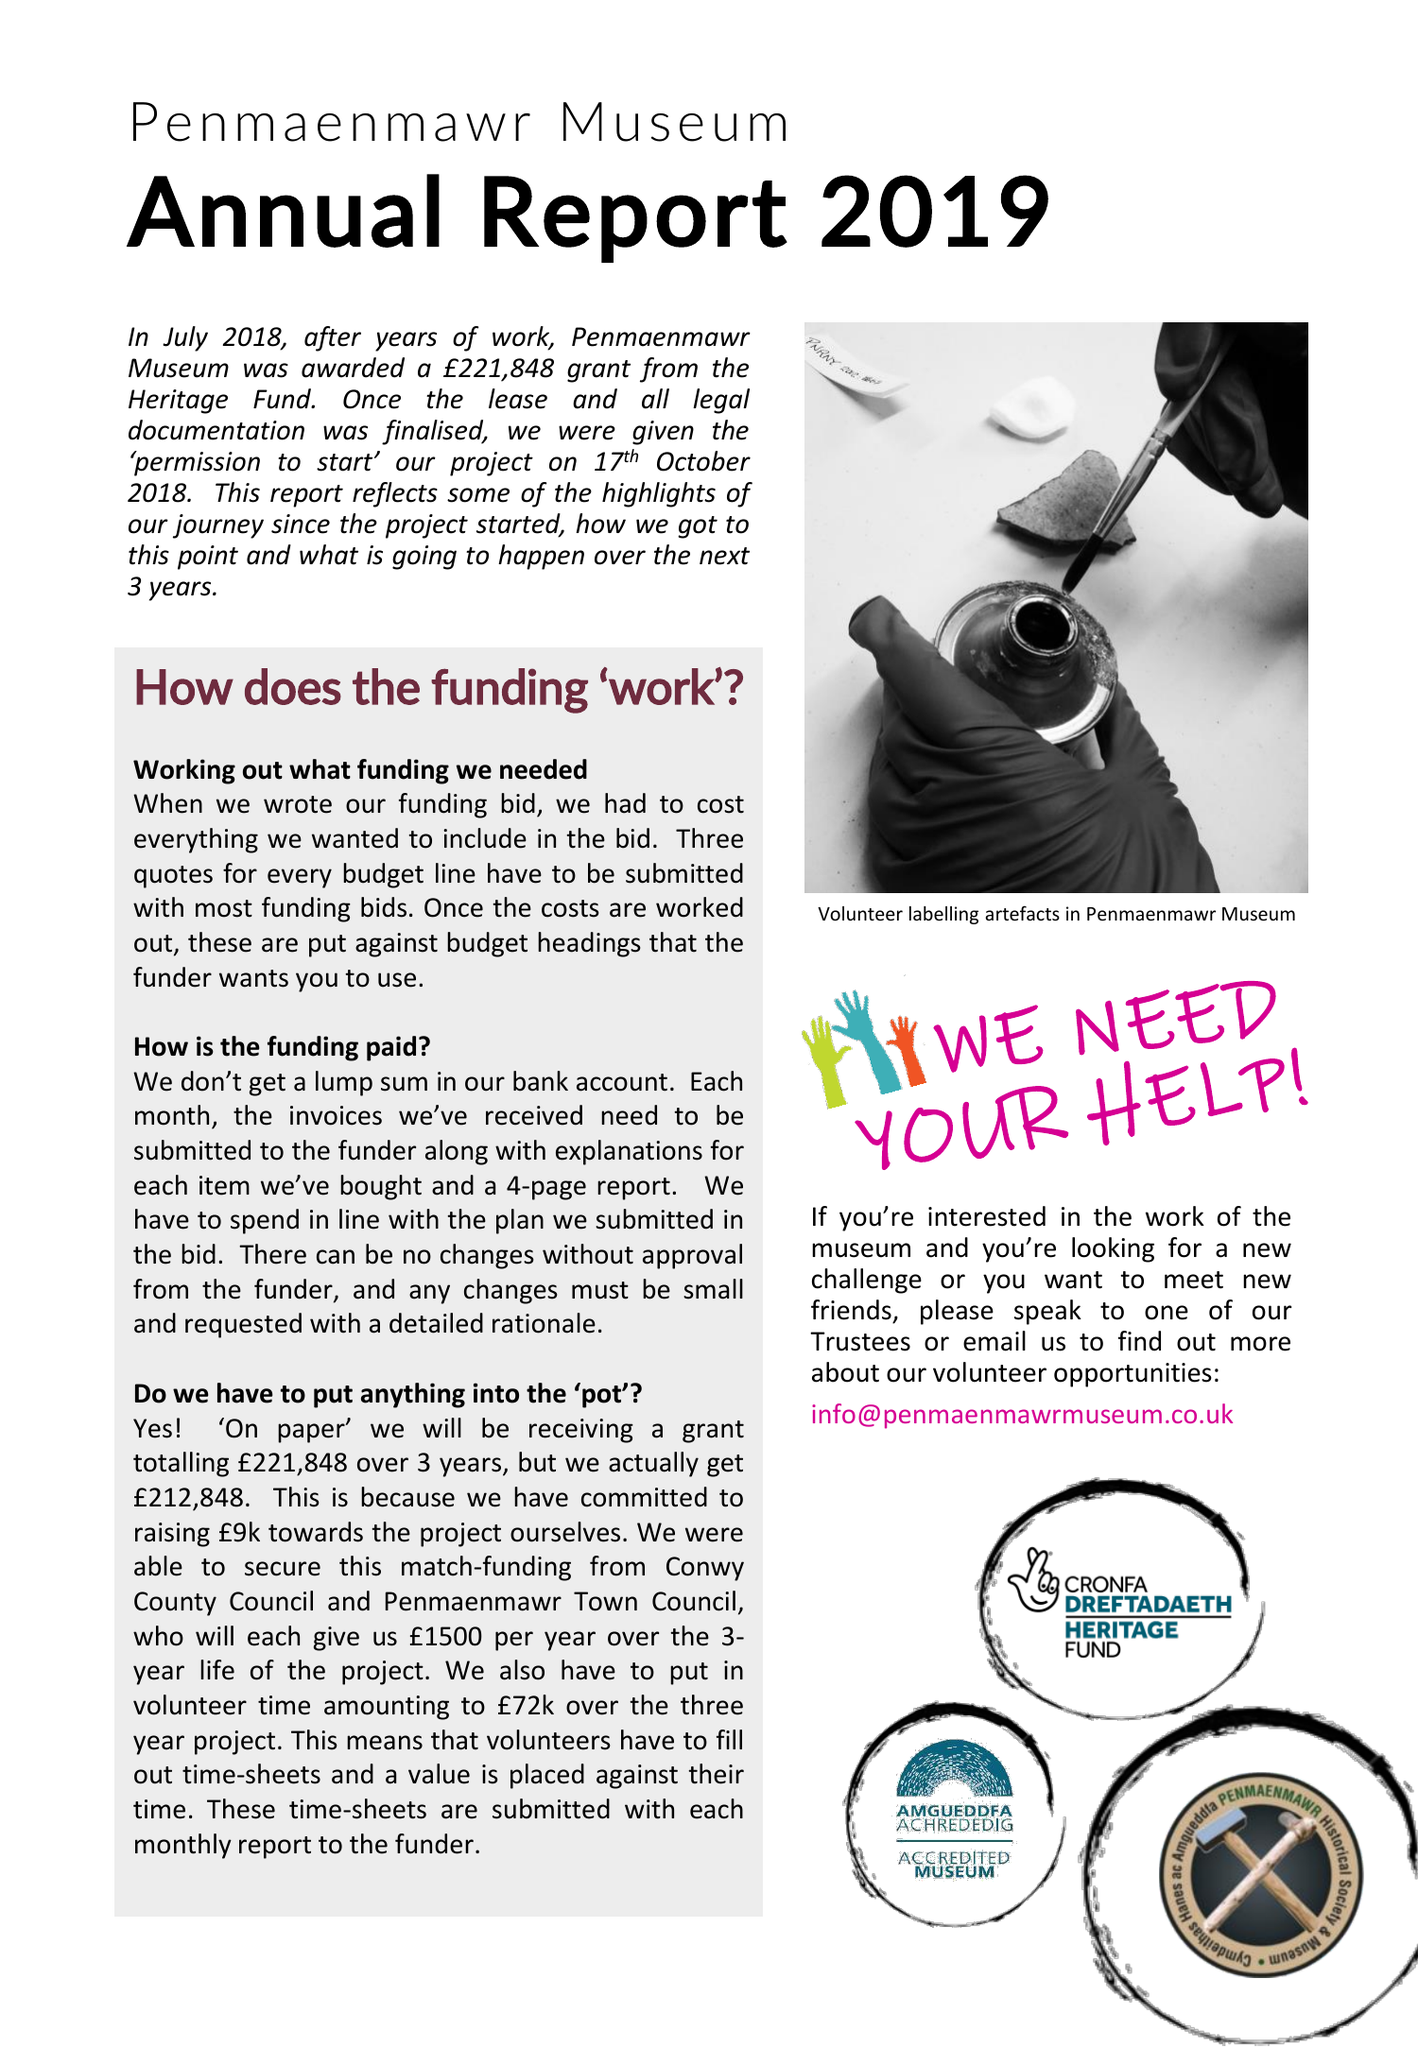What is the value for the report_date?
Answer the question using a single word or phrase. 2019-03-31 